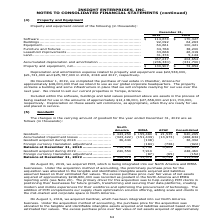According to Insight Enterprises's financial document, How much was Depreciation and amortization expense related to property and equipment  in 2019? According to the financial document, $22,538,000. The relevant text states: "tion expense related to property and equipment was $22,538,000, $21,721,000 and $25,787,000 in 2019, 2018 and 2017, respectively...." Also, How much was Depreciation and amortization expense related to property and equipment  in 2018? According to the financial document, $21,721,000. The relevant text states: "related to property and equipment was $22,538,000, $21,721,000 and $25,787,000 in 2019, 2018 and 2017, respectively...." Also, How much was Depreciation and amortization expense related to property and equipment  in 2017? According to the financial document, $25,787,000. The relevant text states: "rty and equipment was $22,538,000, $21,721,000 and $25,787,000 in 2019, 2018 and 2017, respectively...." Also, can you calculate: What is the change in Software between 2018 and 2019? Based on the calculation: 114,674-170,327, the result is -55653 (in thousands). This is based on the information: "............................................... $ 114,674 $ 170,327 Buildings ............................................................................... ..................................... $ 11..." The key data points involved are: 114,674, 170,327. Also, can you calculate: What is the change in Buildings between 2018 and 2019? Based on the calculation: 92,092-64,263, the result is 27829 (in thousands). This is based on the information: ".......................................... 92,092 64,263 Equipment................................................................................ 60,661 10 .............................................." The key data points involved are: 64,263, 92,092. Also, can you calculate: What is the average Software for 2018 and 2019? To answer this question, I need to perform calculations using the financial data. The calculation is: (114,674+170,327) / 2, which equals 142500.5 (in thousands). This is based on the information: "............................................... $ 114,674 $ 170,327 Buildings ............................................................................... ..................................... $ 11..." The key data points involved are: 114,674, 170,327. 